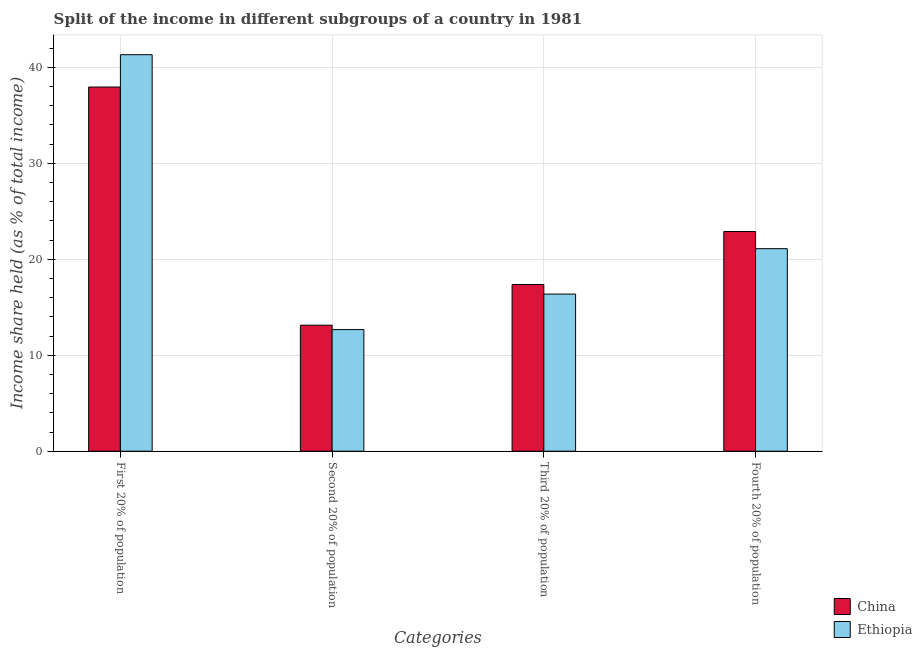How many different coloured bars are there?
Ensure brevity in your answer.  2. How many groups of bars are there?
Provide a short and direct response. 4. Are the number of bars per tick equal to the number of legend labels?
Provide a succinct answer. Yes. Are the number of bars on each tick of the X-axis equal?
Make the answer very short. Yes. How many bars are there on the 3rd tick from the left?
Offer a very short reply. 2. What is the label of the 2nd group of bars from the left?
Give a very brief answer. Second 20% of population. What is the share of the income held by third 20% of the population in China?
Your answer should be very brief. 17.37. Across all countries, what is the maximum share of the income held by first 20% of the population?
Your answer should be compact. 41.31. Across all countries, what is the minimum share of the income held by first 20% of the population?
Keep it short and to the point. 37.94. In which country was the share of the income held by fourth 20% of the population maximum?
Your answer should be very brief. China. In which country was the share of the income held by second 20% of the population minimum?
Your answer should be compact. Ethiopia. What is the total share of the income held by fourth 20% of the population in the graph?
Your response must be concise. 43.99. What is the difference between the share of the income held by fourth 20% of the population in Ethiopia and that in China?
Offer a very short reply. -1.79. What is the difference between the share of the income held by fourth 20% of the population in China and the share of the income held by second 20% of the population in Ethiopia?
Make the answer very short. 10.22. What is the average share of the income held by third 20% of the population per country?
Offer a terse response. 16.87. What is the difference between the share of the income held by third 20% of the population and share of the income held by fourth 20% of the population in Ethiopia?
Keep it short and to the point. -4.73. What is the ratio of the share of the income held by first 20% of the population in China to that in Ethiopia?
Keep it short and to the point. 0.92. Is the difference between the share of the income held by fourth 20% of the population in Ethiopia and China greater than the difference between the share of the income held by third 20% of the population in Ethiopia and China?
Your answer should be very brief. No. What is the difference between the highest and the second highest share of the income held by second 20% of the population?
Your response must be concise. 0.46. What does the 2nd bar from the left in Second 20% of population represents?
Ensure brevity in your answer.  Ethiopia. What does the 1st bar from the right in Fourth 20% of population represents?
Keep it short and to the point. Ethiopia. Are all the bars in the graph horizontal?
Offer a terse response. No. How many countries are there in the graph?
Give a very brief answer. 2. What is the difference between two consecutive major ticks on the Y-axis?
Provide a short and direct response. 10. Are the values on the major ticks of Y-axis written in scientific E-notation?
Keep it short and to the point. No. Does the graph contain grids?
Your response must be concise. Yes. How many legend labels are there?
Your response must be concise. 2. How are the legend labels stacked?
Offer a very short reply. Vertical. What is the title of the graph?
Keep it short and to the point. Split of the income in different subgroups of a country in 1981. Does "High income" appear as one of the legend labels in the graph?
Provide a succinct answer. No. What is the label or title of the X-axis?
Offer a terse response. Categories. What is the label or title of the Y-axis?
Your response must be concise. Income share held (as % of total income). What is the Income share held (as % of total income) in China in First 20% of population?
Your answer should be compact. 37.94. What is the Income share held (as % of total income) of Ethiopia in First 20% of population?
Ensure brevity in your answer.  41.31. What is the Income share held (as % of total income) of China in Second 20% of population?
Offer a very short reply. 13.13. What is the Income share held (as % of total income) of Ethiopia in Second 20% of population?
Provide a succinct answer. 12.67. What is the Income share held (as % of total income) in China in Third 20% of population?
Make the answer very short. 17.37. What is the Income share held (as % of total income) in Ethiopia in Third 20% of population?
Offer a terse response. 16.37. What is the Income share held (as % of total income) of China in Fourth 20% of population?
Your answer should be compact. 22.89. What is the Income share held (as % of total income) in Ethiopia in Fourth 20% of population?
Your answer should be compact. 21.1. Across all Categories, what is the maximum Income share held (as % of total income) of China?
Offer a terse response. 37.94. Across all Categories, what is the maximum Income share held (as % of total income) of Ethiopia?
Provide a succinct answer. 41.31. Across all Categories, what is the minimum Income share held (as % of total income) of China?
Offer a very short reply. 13.13. Across all Categories, what is the minimum Income share held (as % of total income) of Ethiopia?
Offer a very short reply. 12.67. What is the total Income share held (as % of total income) of China in the graph?
Give a very brief answer. 91.33. What is the total Income share held (as % of total income) in Ethiopia in the graph?
Your response must be concise. 91.45. What is the difference between the Income share held (as % of total income) in China in First 20% of population and that in Second 20% of population?
Provide a succinct answer. 24.81. What is the difference between the Income share held (as % of total income) in Ethiopia in First 20% of population and that in Second 20% of population?
Keep it short and to the point. 28.64. What is the difference between the Income share held (as % of total income) of China in First 20% of population and that in Third 20% of population?
Offer a terse response. 20.57. What is the difference between the Income share held (as % of total income) in Ethiopia in First 20% of population and that in Third 20% of population?
Your answer should be compact. 24.94. What is the difference between the Income share held (as % of total income) in China in First 20% of population and that in Fourth 20% of population?
Give a very brief answer. 15.05. What is the difference between the Income share held (as % of total income) in Ethiopia in First 20% of population and that in Fourth 20% of population?
Give a very brief answer. 20.21. What is the difference between the Income share held (as % of total income) of China in Second 20% of population and that in Third 20% of population?
Provide a short and direct response. -4.24. What is the difference between the Income share held (as % of total income) of Ethiopia in Second 20% of population and that in Third 20% of population?
Keep it short and to the point. -3.7. What is the difference between the Income share held (as % of total income) in China in Second 20% of population and that in Fourth 20% of population?
Ensure brevity in your answer.  -9.76. What is the difference between the Income share held (as % of total income) of Ethiopia in Second 20% of population and that in Fourth 20% of population?
Provide a short and direct response. -8.43. What is the difference between the Income share held (as % of total income) of China in Third 20% of population and that in Fourth 20% of population?
Provide a succinct answer. -5.52. What is the difference between the Income share held (as % of total income) of Ethiopia in Third 20% of population and that in Fourth 20% of population?
Your answer should be very brief. -4.73. What is the difference between the Income share held (as % of total income) in China in First 20% of population and the Income share held (as % of total income) in Ethiopia in Second 20% of population?
Ensure brevity in your answer.  25.27. What is the difference between the Income share held (as % of total income) in China in First 20% of population and the Income share held (as % of total income) in Ethiopia in Third 20% of population?
Keep it short and to the point. 21.57. What is the difference between the Income share held (as % of total income) in China in First 20% of population and the Income share held (as % of total income) in Ethiopia in Fourth 20% of population?
Make the answer very short. 16.84. What is the difference between the Income share held (as % of total income) of China in Second 20% of population and the Income share held (as % of total income) of Ethiopia in Third 20% of population?
Provide a short and direct response. -3.24. What is the difference between the Income share held (as % of total income) in China in Second 20% of population and the Income share held (as % of total income) in Ethiopia in Fourth 20% of population?
Give a very brief answer. -7.97. What is the difference between the Income share held (as % of total income) of China in Third 20% of population and the Income share held (as % of total income) of Ethiopia in Fourth 20% of population?
Give a very brief answer. -3.73. What is the average Income share held (as % of total income) in China per Categories?
Keep it short and to the point. 22.83. What is the average Income share held (as % of total income) in Ethiopia per Categories?
Give a very brief answer. 22.86. What is the difference between the Income share held (as % of total income) of China and Income share held (as % of total income) of Ethiopia in First 20% of population?
Give a very brief answer. -3.37. What is the difference between the Income share held (as % of total income) in China and Income share held (as % of total income) in Ethiopia in Second 20% of population?
Your answer should be compact. 0.46. What is the difference between the Income share held (as % of total income) of China and Income share held (as % of total income) of Ethiopia in Fourth 20% of population?
Provide a short and direct response. 1.79. What is the ratio of the Income share held (as % of total income) in China in First 20% of population to that in Second 20% of population?
Give a very brief answer. 2.89. What is the ratio of the Income share held (as % of total income) in Ethiopia in First 20% of population to that in Second 20% of population?
Provide a succinct answer. 3.26. What is the ratio of the Income share held (as % of total income) of China in First 20% of population to that in Third 20% of population?
Make the answer very short. 2.18. What is the ratio of the Income share held (as % of total income) of Ethiopia in First 20% of population to that in Third 20% of population?
Offer a very short reply. 2.52. What is the ratio of the Income share held (as % of total income) of China in First 20% of population to that in Fourth 20% of population?
Provide a short and direct response. 1.66. What is the ratio of the Income share held (as % of total income) of Ethiopia in First 20% of population to that in Fourth 20% of population?
Keep it short and to the point. 1.96. What is the ratio of the Income share held (as % of total income) of China in Second 20% of population to that in Third 20% of population?
Give a very brief answer. 0.76. What is the ratio of the Income share held (as % of total income) in Ethiopia in Second 20% of population to that in Third 20% of population?
Keep it short and to the point. 0.77. What is the ratio of the Income share held (as % of total income) in China in Second 20% of population to that in Fourth 20% of population?
Give a very brief answer. 0.57. What is the ratio of the Income share held (as % of total income) in Ethiopia in Second 20% of population to that in Fourth 20% of population?
Give a very brief answer. 0.6. What is the ratio of the Income share held (as % of total income) in China in Third 20% of population to that in Fourth 20% of population?
Ensure brevity in your answer.  0.76. What is the ratio of the Income share held (as % of total income) in Ethiopia in Third 20% of population to that in Fourth 20% of population?
Offer a very short reply. 0.78. What is the difference between the highest and the second highest Income share held (as % of total income) of China?
Offer a very short reply. 15.05. What is the difference between the highest and the second highest Income share held (as % of total income) of Ethiopia?
Give a very brief answer. 20.21. What is the difference between the highest and the lowest Income share held (as % of total income) of China?
Offer a very short reply. 24.81. What is the difference between the highest and the lowest Income share held (as % of total income) of Ethiopia?
Provide a succinct answer. 28.64. 